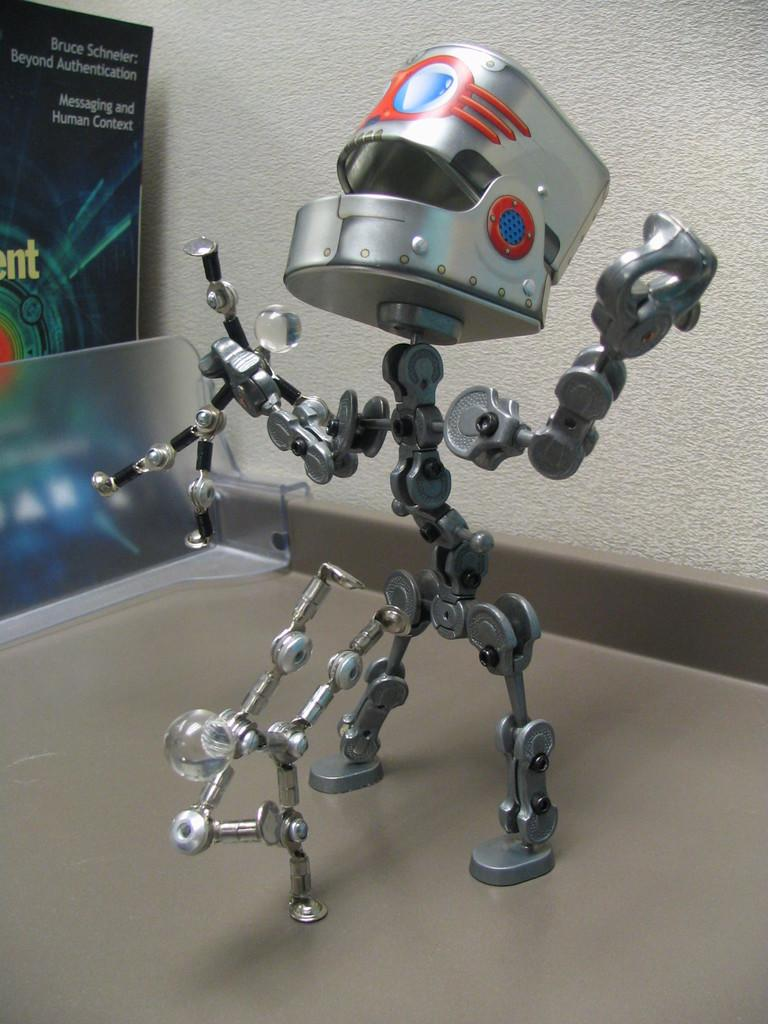What is the main subject of the image? There is a robot in the image. Where is the robot located? The robot is on the floor. What can be seen in the background of the image? There is a wall in the background of the image. What type of wrench is the robot using to fix the broken head in the image? There is no wrench or broken head present in the image; it only features a robot on the floor with a wall in the background. 